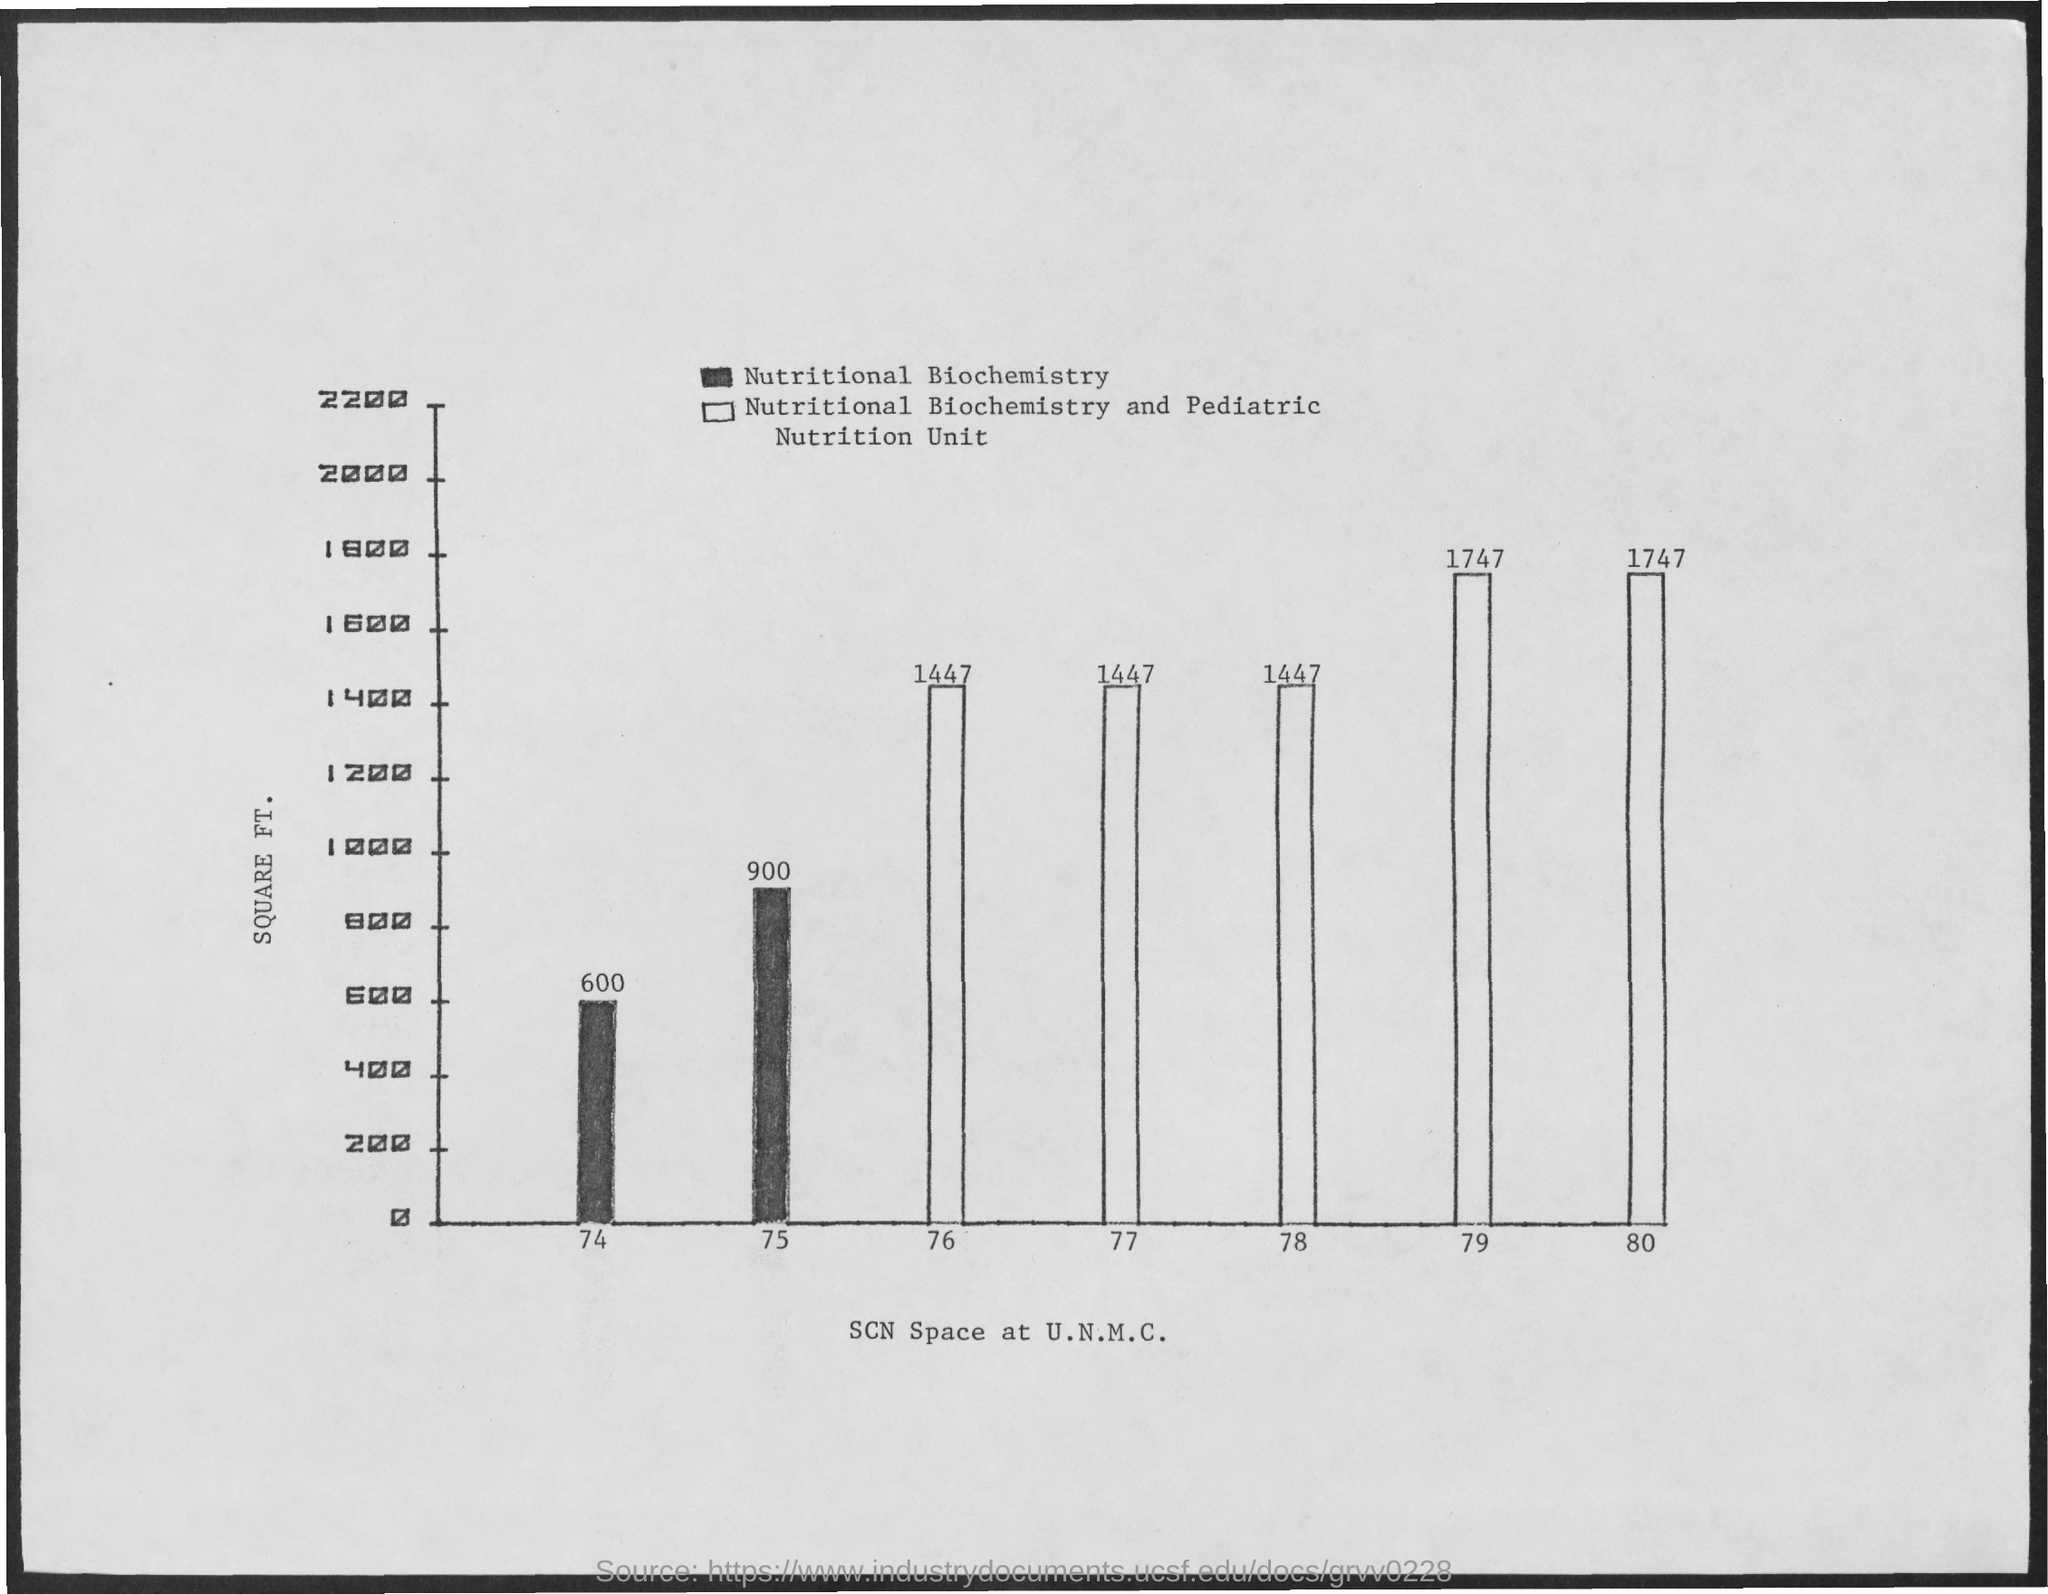Mention a couple of crucial points in this snapshot. What is the Y axis for the graph? It represents the square footage of the finished space. The SCN Space at the University of New Mexico Cancer Center in 1974 was approximately 600 square feet in size. The SCN Space at the University of New Mexico Cancer Center in 1979 was operational and had a staff of 1747. The SCN Space at the University of New Mexico Comprehensive Cancer Center is located at 1447. The SCN Space at the University of North Carolina at Chapel Hill was established in 1978. It is a designated area for students, faculty, and staff to collaborate and engage in academic pursuits. 